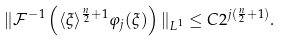<formula> <loc_0><loc_0><loc_500><loc_500>\| \mathcal { F } ^ { - 1 } \left ( \langle \xi \rangle ^ { \frac { n } { 2 } + 1 } \varphi _ { j } ( \xi ) \right ) \| _ { L ^ { 1 } } \leq C 2 ^ { j ( \frac { n } { 2 } + 1 ) } .</formula> 